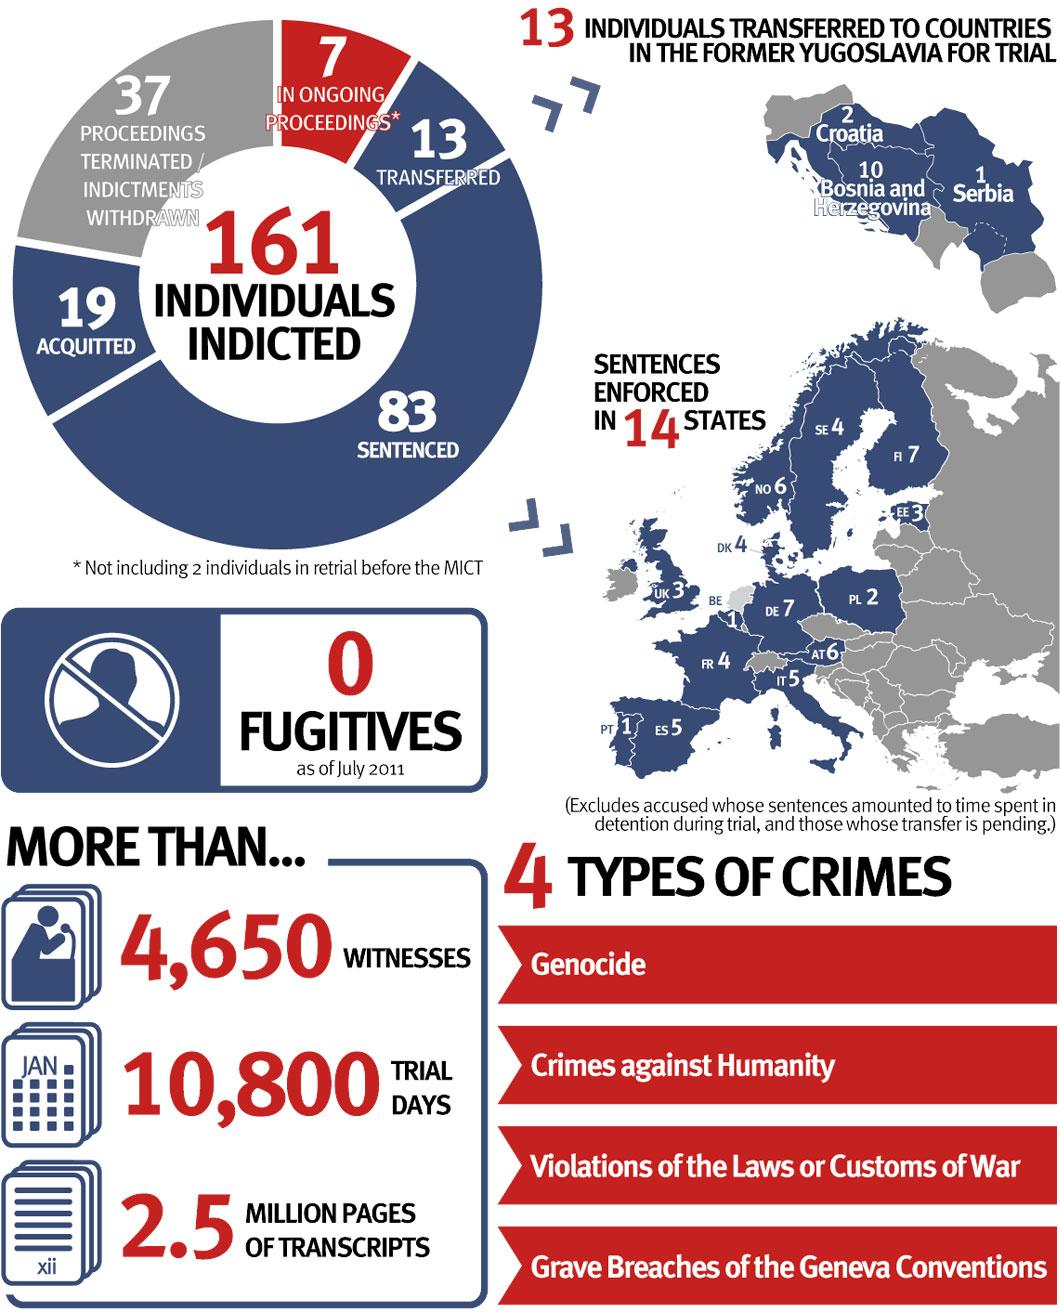Identify some key points in this picture. According to the infographic, genocide and crimes against humanity are the top two crimes in terms of number of cases. Thirteen individuals were transferred to several countries in former Yugoslavia, including Croatia, Bosnia and Herzegovina, and Serbia. Ninety-six people were transferred and sentenced. 